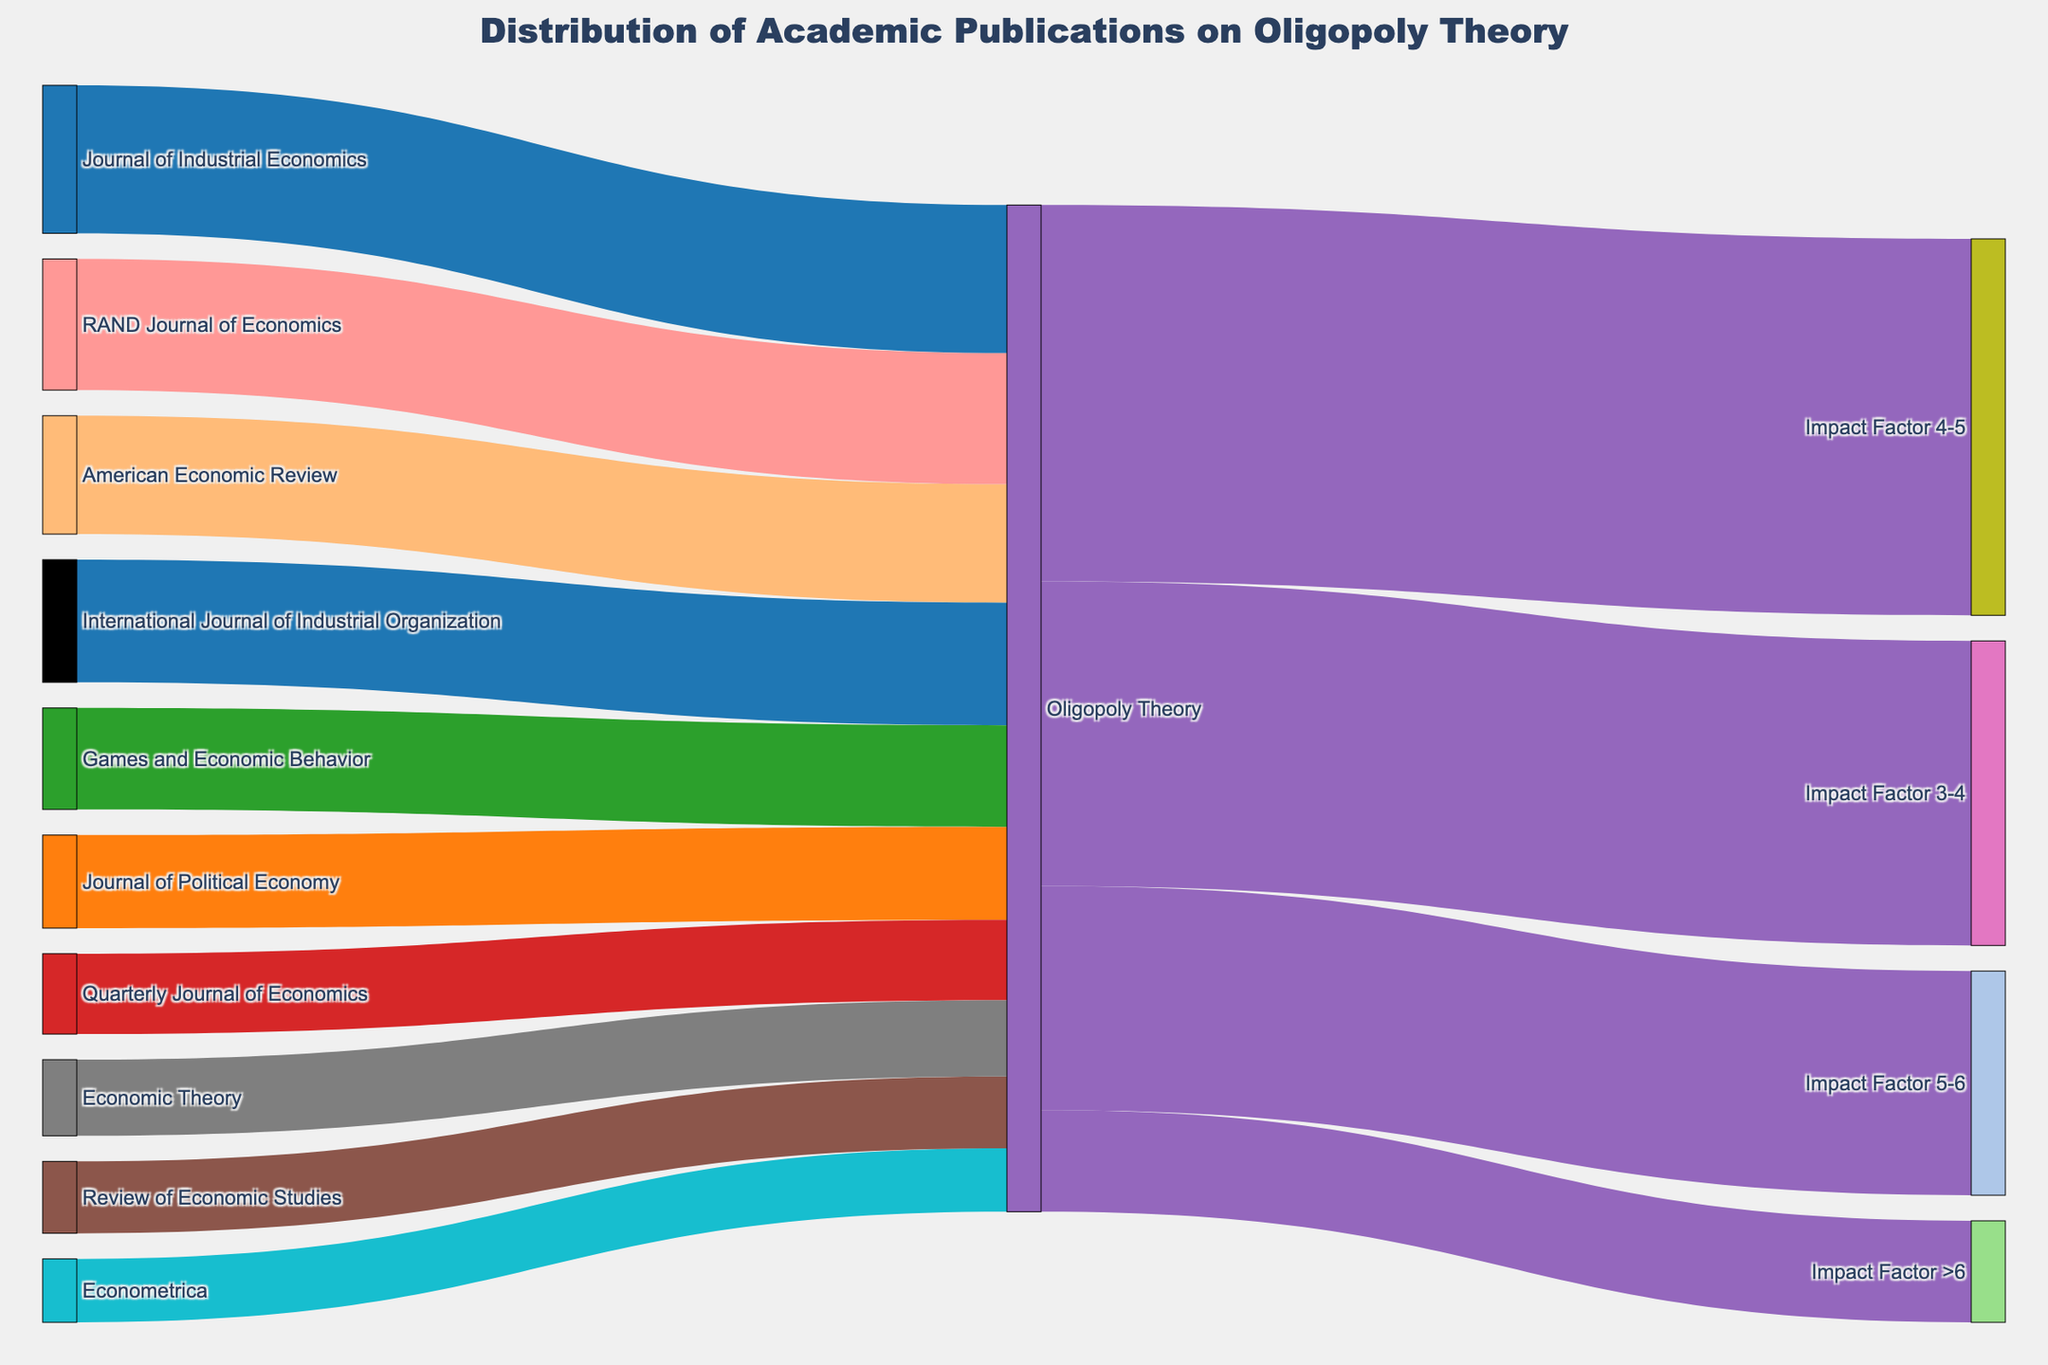What is the title of the figure? The title is found at the top of the figure and provides a brief description of the visual representation.
Answer: Distribution of Academic Publications on Oligopoly Theory Which economic journal has the highest number of publications on oligopoly theory? Look at the sources connecting to "Oligopoly Theory" and identify the one with the largest value.
Answer: Journal of Industrial Economics How many total publications on oligopoly theory are there across all journals? Sum the values from each journal source connecting to "Oligopoly Theory". The sum is 28+22+19+15+17+31+35+29+24+18.
Answer: 238 Which impact factor range has the most publications on oligopoly theory? Look at the targets "Impact Factor 3-4", "Impact Factor 4-5", "Impact Factor 5-6", and "Impact Factor >6" and compare their values.
Answer: Impact Factor 4-5 How many publications from journals with an impact factor greater than 6 are there? Find the value connecting from "Oligopoly Theory" to "Impact Factor >6".
Answer: 24 How many more publications are there in journals with an impact factor of 3-4 compared to greater than 6? Subtract the value of "Impact Factor >6" from "Impact Factor 3-4". The difference is 72 - 24.
Answer: 48 Is there a journal with over 30 publications on oligopoly theory? If so, which one? Evaluate if any values from a journal source to "Oligopoly Theory" are greater than 30.
Answer: Yes, Journal of Industrial Economics (35) and RAND Journal of Economics (31) On average, how many publications on oligopoly theory does each journal contribute? Divide the total number of publications (238) by the number of journals. There are 10 journals.
Answer: 23.8 Which has more publications: combined 'American Economic Review' and 'Econometrica' or 'Journal of Political Economy' and 'Economic Theory'? Add the values of each pair and compare them. 'American Economic Review' and 'Econometrica' have 28+15=43, while 'Journal of Political Economy' and 'Economic Theory' have 22+18=40.
Answer: American Economic Review and Econometrica 